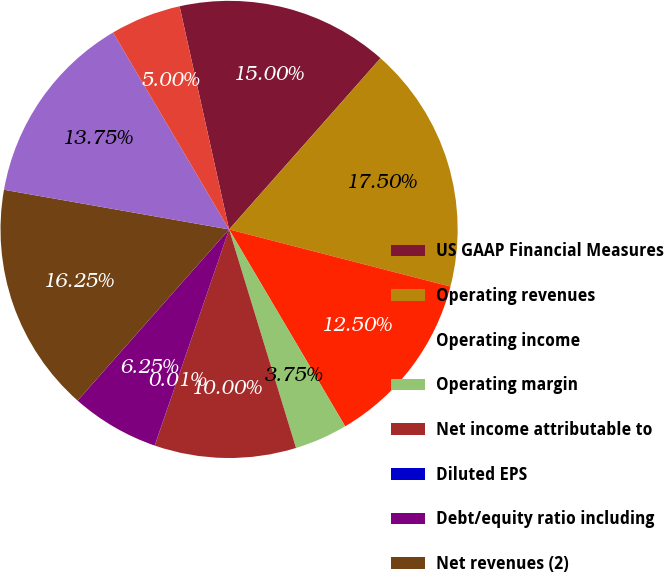<chart> <loc_0><loc_0><loc_500><loc_500><pie_chart><fcel>US GAAP Financial Measures<fcel>Operating revenues<fcel>Operating income<fcel>Operating margin<fcel>Net income attributable to<fcel>Diluted EPS<fcel>Debt/equity ratio including<fcel>Net revenues (2)<fcel>Adjusted operating income (3)<fcel>Adjusted operating margin (3)<nl><fcel>15.0%<fcel>17.5%<fcel>12.5%<fcel>3.75%<fcel>10.0%<fcel>0.01%<fcel>6.25%<fcel>16.25%<fcel>13.75%<fcel>5.0%<nl></chart> 